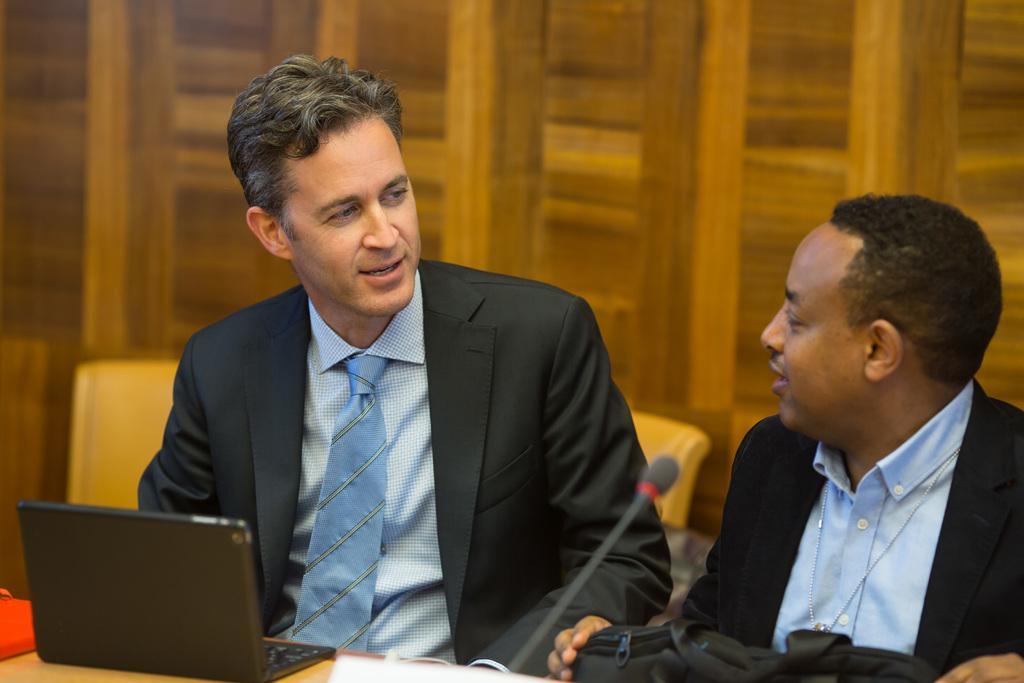Describe this image in one or two sentences. In this image there are people, there is mike, there is a table with objects on it in the foreground. There are chairs and it looks like a wooden object in the background. 